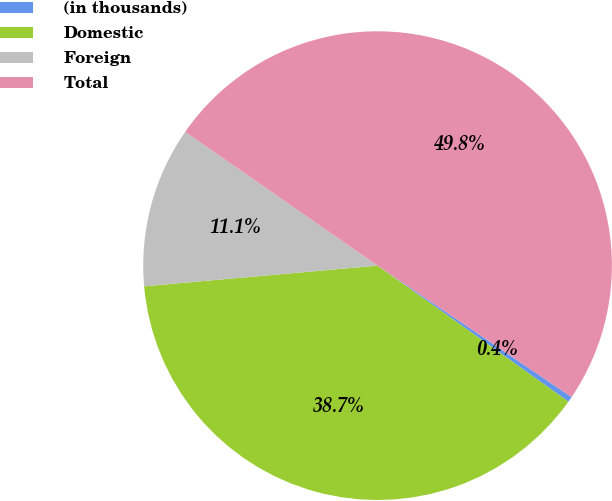<chart> <loc_0><loc_0><loc_500><loc_500><pie_chart><fcel>(in thousands)<fcel>Domestic<fcel>Foreign<fcel>Total<nl><fcel>0.38%<fcel>38.74%<fcel>11.08%<fcel>49.81%<nl></chart> 